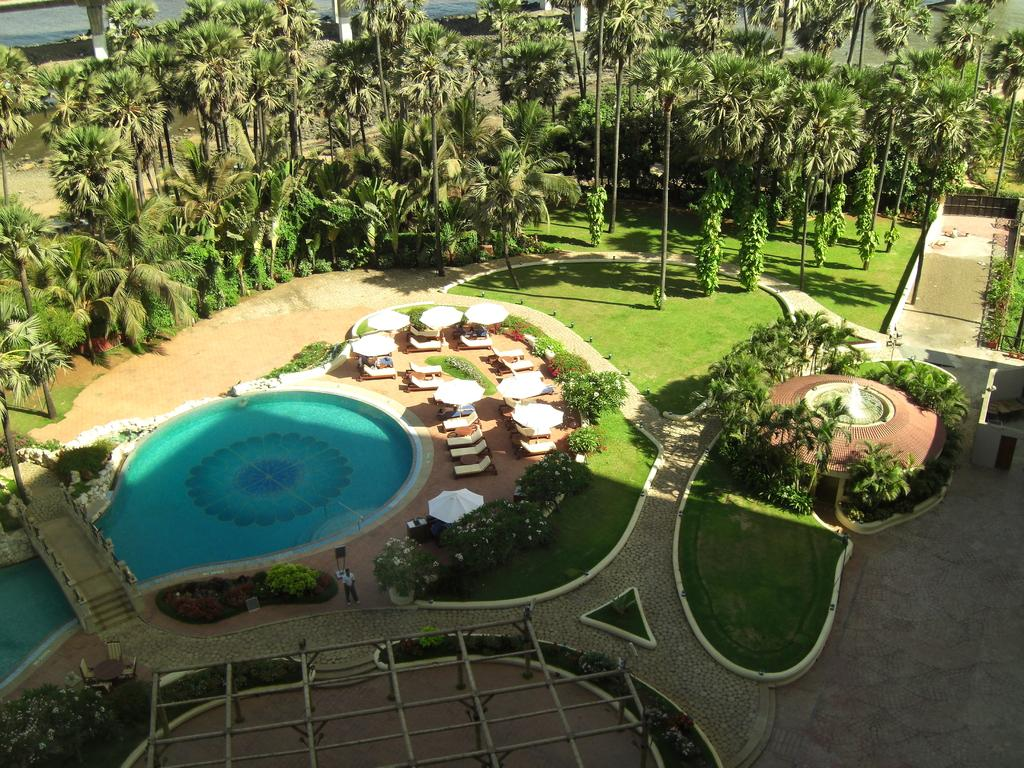What is the main feature of the image? There is a swimming pool in the image. What type of furniture is present in the image? Chairs and tables are in the image. Can you describe the person near the pool? There is a person near the pool. What type of vegetation can be seen in the image? Garden plants, trees, and grass are visible in the image. What architectural elements are present in the image? Stone pillars are in the image. What type of temporary shelter is present in the image? There is a wooden tent in the image. Where is the harbor located in the image? There is no harbor present in the image. Can you describe the expert who is providing advice near the pool? There is no expert present in the image, nor is there any indication that someone is providing advice. 